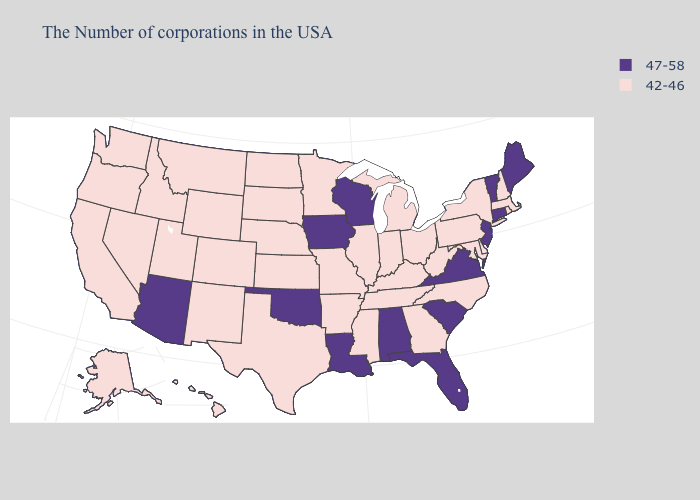Does West Virginia have a lower value than Oklahoma?
Quick response, please. Yes. Which states have the lowest value in the West?
Concise answer only. Wyoming, Colorado, New Mexico, Utah, Montana, Idaho, Nevada, California, Washington, Oregon, Alaska, Hawaii. Does South Dakota have the highest value in the USA?
Be succinct. No. What is the value of Missouri?
Keep it brief. 42-46. What is the value of Wisconsin?
Write a very short answer. 47-58. What is the value of Maine?
Short answer required. 47-58. Does the map have missing data?
Give a very brief answer. No. Name the states that have a value in the range 42-46?
Concise answer only. Massachusetts, Rhode Island, New Hampshire, New York, Delaware, Maryland, Pennsylvania, North Carolina, West Virginia, Ohio, Georgia, Michigan, Kentucky, Indiana, Tennessee, Illinois, Mississippi, Missouri, Arkansas, Minnesota, Kansas, Nebraska, Texas, South Dakota, North Dakota, Wyoming, Colorado, New Mexico, Utah, Montana, Idaho, Nevada, California, Washington, Oregon, Alaska, Hawaii. Among the states that border Rhode Island , which have the highest value?
Write a very short answer. Connecticut. What is the highest value in states that border California?
Give a very brief answer. 47-58. Name the states that have a value in the range 42-46?
Be succinct. Massachusetts, Rhode Island, New Hampshire, New York, Delaware, Maryland, Pennsylvania, North Carolina, West Virginia, Ohio, Georgia, Michigan, Kentucky, Indiana, Tennessee, Illinois, Mississippi, Missouri, Arkansas, Minnesota, Kansas, Nebraska, Texas, South Dakota, North Dakota, Wyoming, Colorado, New Mexico, Utah, Montana, Idaho, Nevada, California, Washington, Oregon, Alaska, Hawaii. Does Missouri have a lower value than Vermont?
Short answer required. Yes. What is the lowest value in the USA?
Keep it brief. 42-46. Does the map have missing data?
Quick response, please. No. Does Utah have the highest value in the West?
Short answer required. No. 